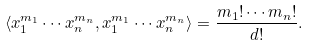Convert formula to latex. <formula><loc_0><loc_0><loc_500><loc_500>\langle x _ { 1 } ^ { m _ { 1 } } \cdots x _ { n } ^ { m _ { n } } , x _ { 1 } ^ { m _ { 1 } } \cdots x _ { n } ^ { m _ { n } } \rangle = \frac { m _ { 1 } ! \cdots m _ { n } ! } { d ! } .</formula> 